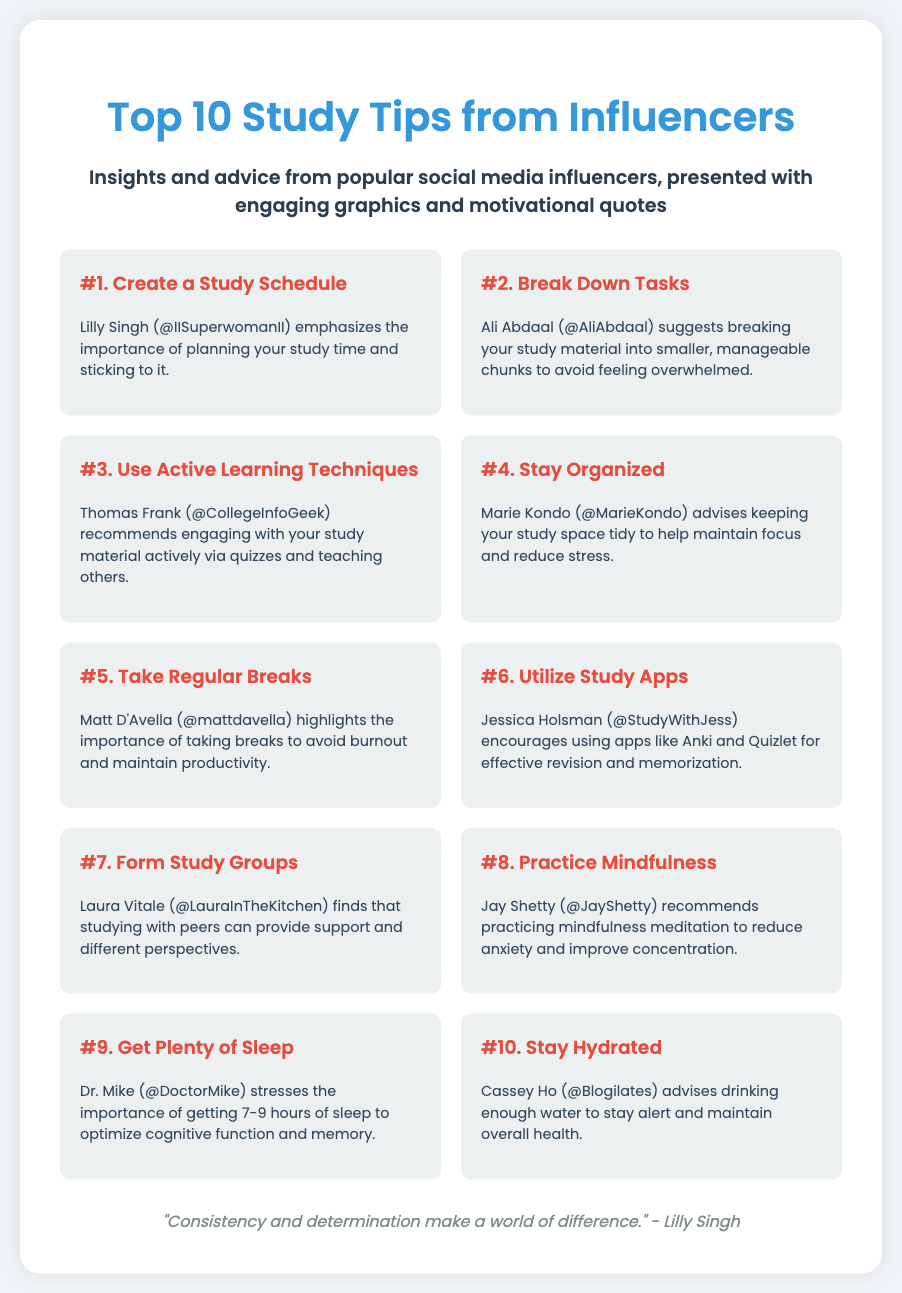What is the title of the poster? The title is provided in the header section of the document, stating the main focus of the content.
Answer: Top 10 Study Tips from Influencers How many study tips are presented in the poster? The number of tips is highlighted in the title, indicating a specific count of the tips.
Answer: 10 Who is associated with the tip "Create a Study Schedule"? This information is identified in the first tip and its corresponding influencer.
Answer: Lilly Singh What does Matt D'Avella emphasize in his tip? The specific focus of Matt D'Avella's tip is mentioned directly under his name.
Answer: Taking breaks Which influencer suggests using study apps? The influencer related to this advice can be found in the corresponding tip section.
Answer: Jessica Holsman What is the main purpose of the poster? The purpose can be inferred from the introductory text that provides context for the content.
Answer: To provide study tips Which tip focuses on mindfulness? The description of the tip regarding mindfulness includes the name of the influencer.
Answer: #8. Practice Mindfulness What motivational theme is concluded at the bottom of the poster? The concluding theme is derived from the footer quote, emphasizing the overall message.
Answer: Consistency and determination 